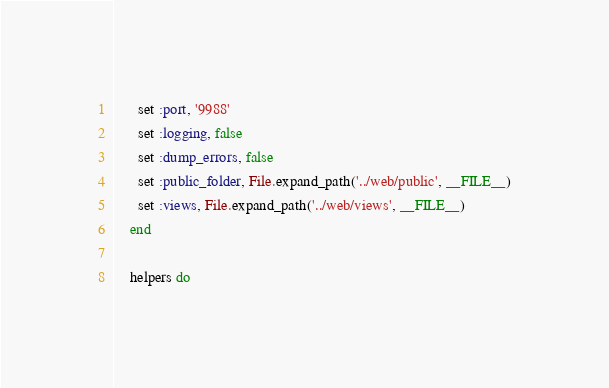<code> <loc_0><loc_0><loc_500><loc_500><_Ruby_>      set :port, '9988' 
      set :logging, false 
      set :dump_errors, false
      set :public_folder, File.expand_path('../web/public', __FILE__)
      set :views, File.expand_path('../web/views', __FILE__)
    end

    helpers do</code> 